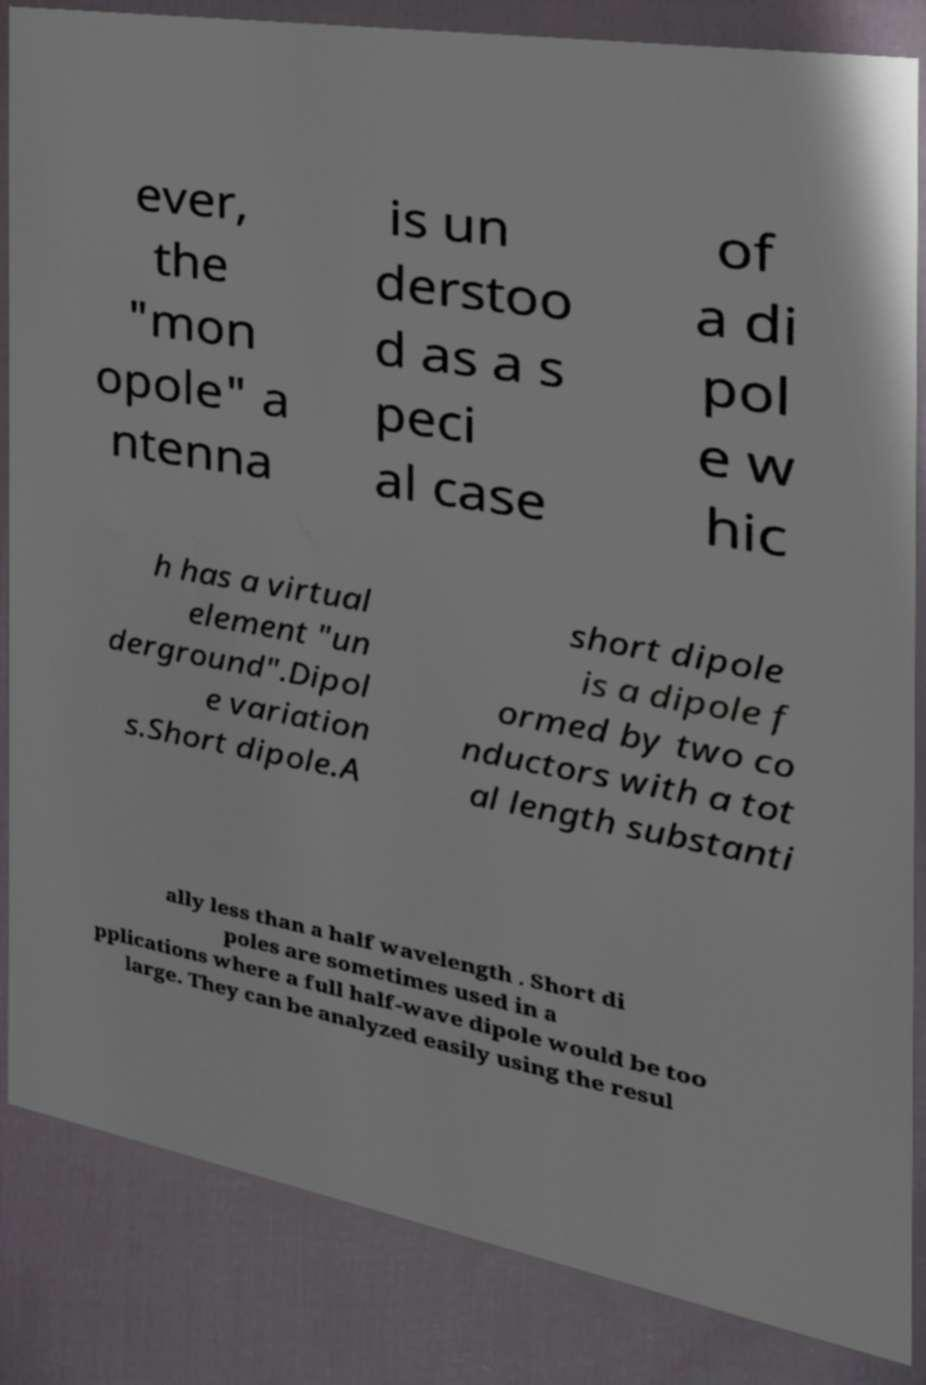Could you assist in decoding the text presented in this image and type it out clearly? ever, the "mon opole" a ntenna is un derstoo d as a s peci al case of a di pol e w hic h has a virtual element "un derground".Dipol e variation s.Short dipole.A short dipole is a dipole f ormed by two co nductors with a tot al length substanti ally less than a half wavelength . Short di poles are sometimes used in a pplications where a full half-wave dipole would be too large. They can be analyzed easily using the resul 